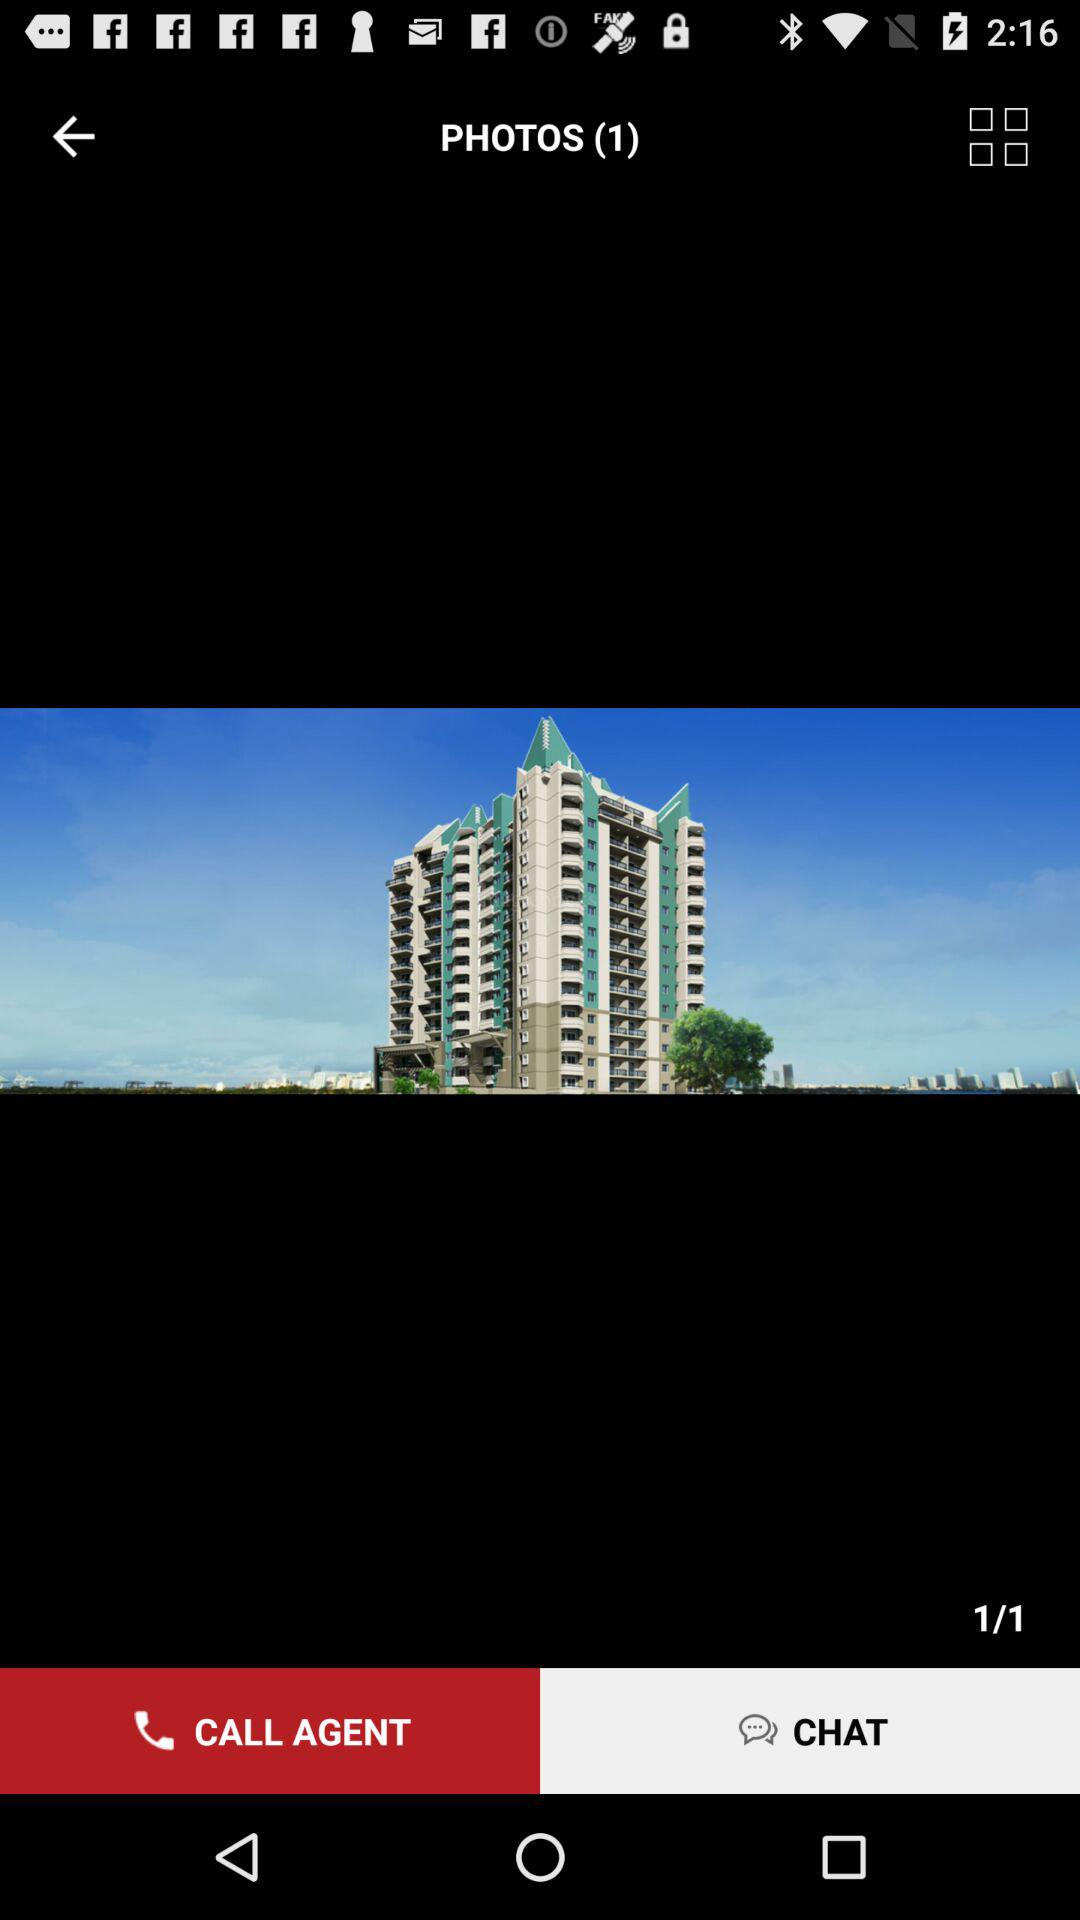What's the total number of slides? The total number of slides is 1. 